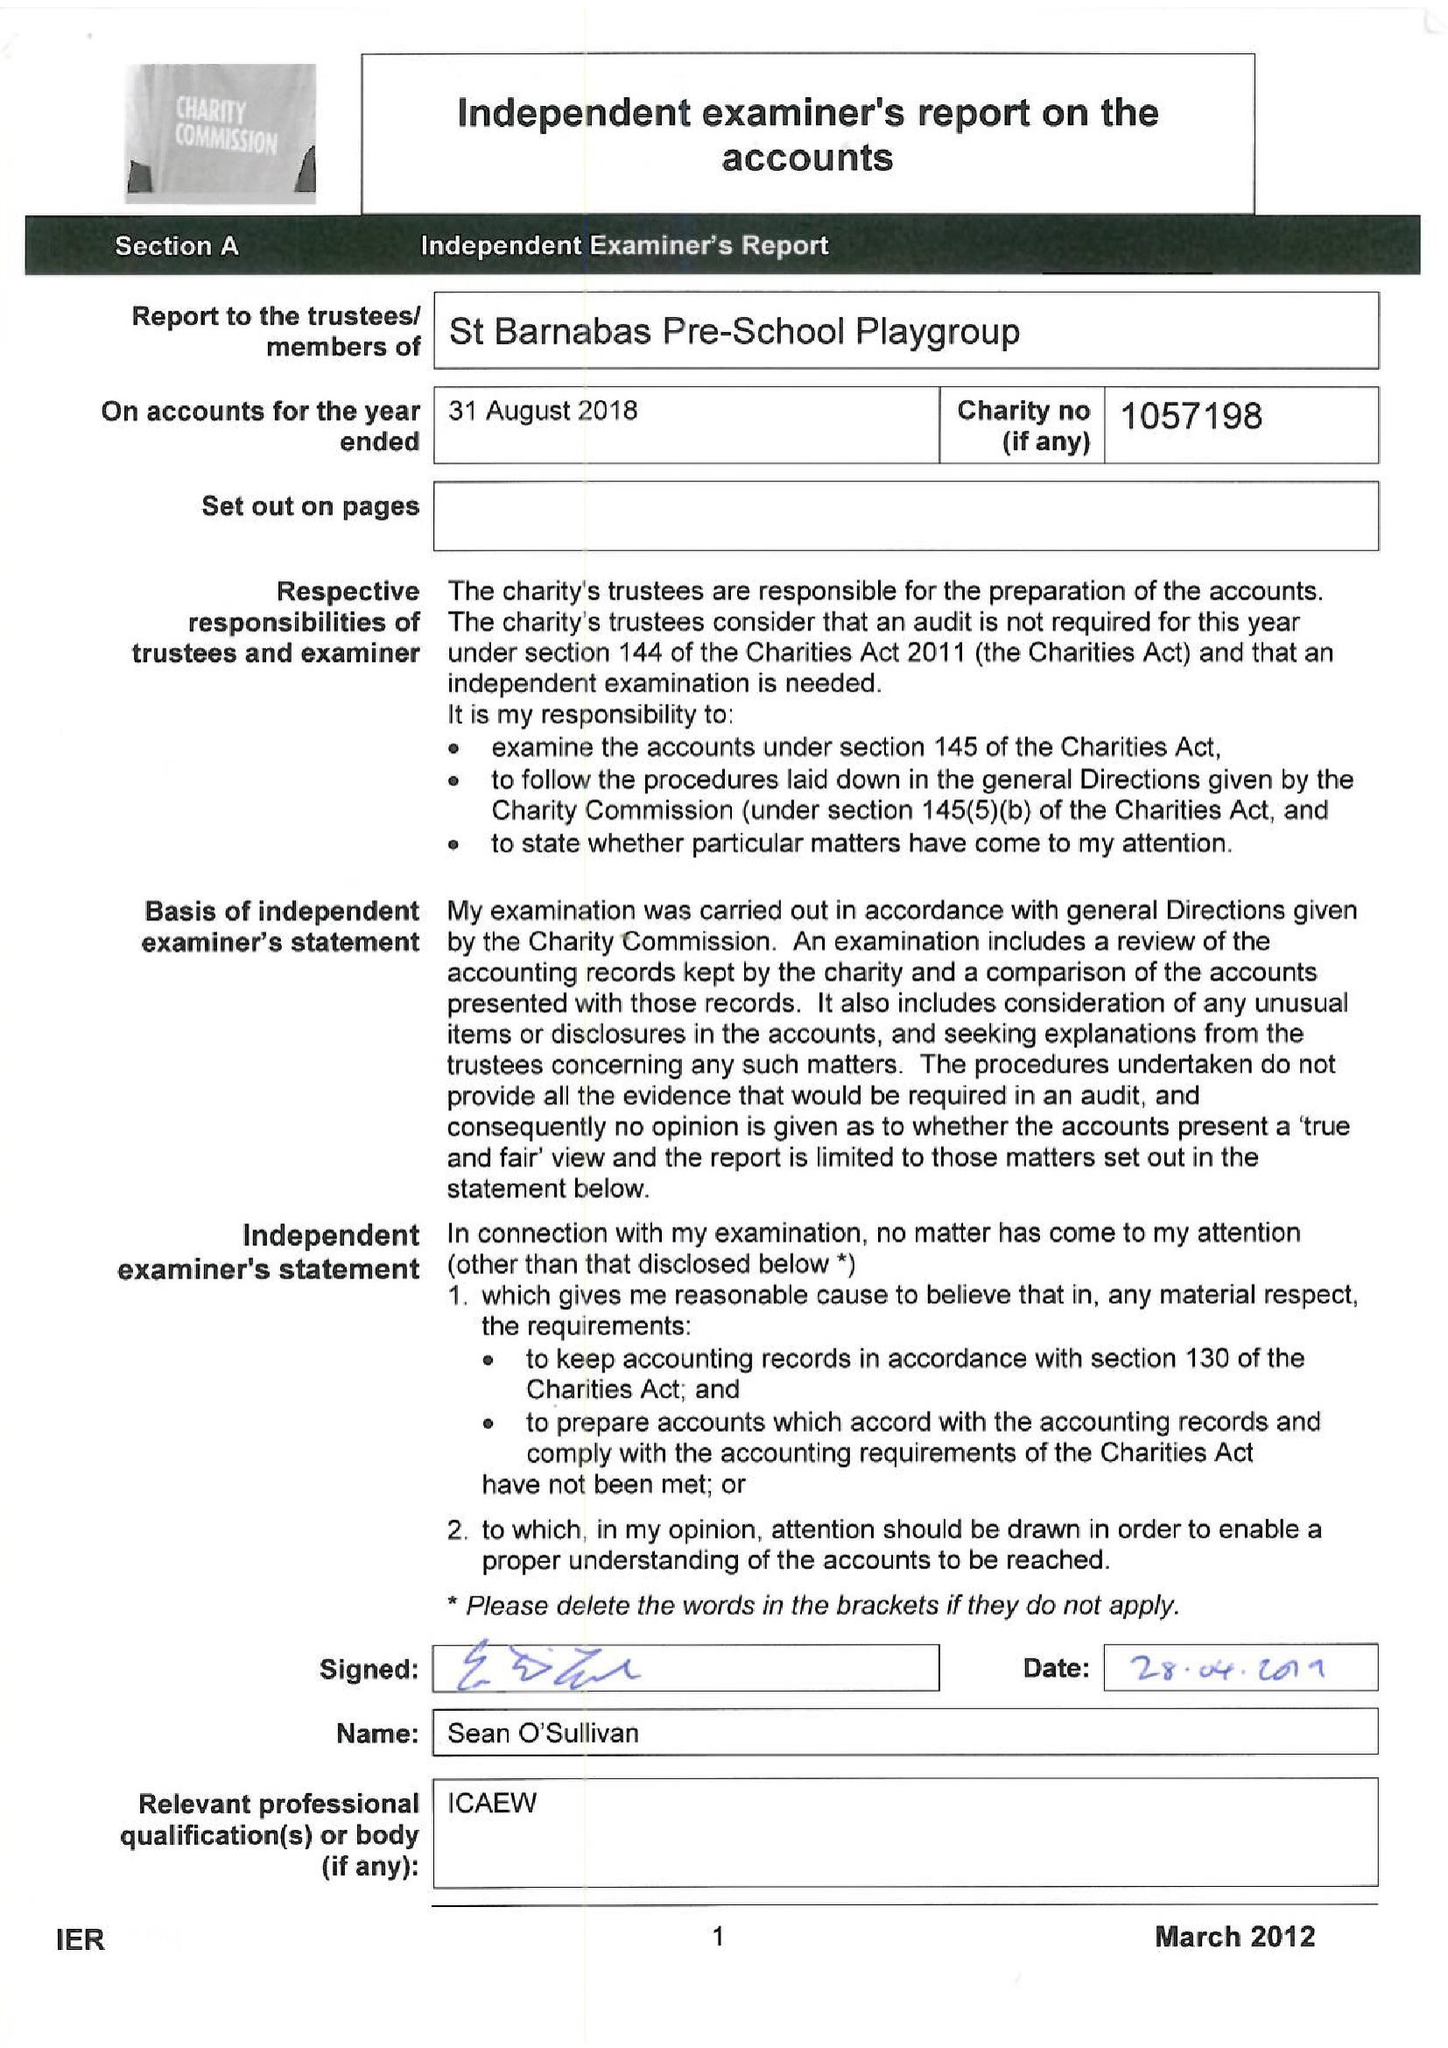What is the value for the charity_number?
Answer the question using a single word or phrase. 1057198 